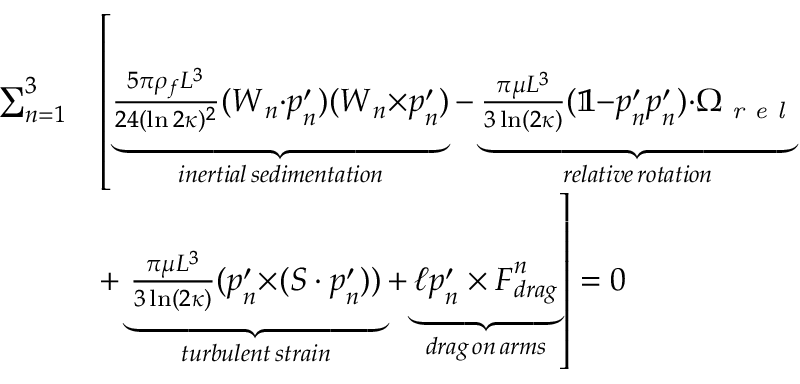<formula> <loc_0><loc_0><loc_500><loc_500>\begin{array} { r l } { \sum _ { n = 1 } ^ { 3 } } & { \left [ \underbrace { \frac { 5 \pi \rho _ { f } L ^ { 3 } } { 2 4 ( \ln 2 \kappa ) ^ { 2 } } ( W _ { n } { \cdot } p _ { n } ^ { \prime } ) ( W _ { n } { \times } p _ { n } ^ { \prime } ) } _ { i n e r t i a l \, s e d i m e n t a t i o n } - \underbrace { \frac { \pi \mu L ^ { 3 } } { 3 \ln ( 2 \kappa ) } ( \mathbb { 1 } { - } p _ { n } ^ { \prime } p _ { n } ^ { \prime } ) { \cdot } \Omega _ { r e l } } _ { r e l a t i v e \, r o t a t i o n } } \\ & { + \underbrace { \frac { \pi \mu L ^ { 3 } } { 3 \ln ( 2 \kappa ) } ( p _ { n } ^ { \prime } { \times } ( S \cdot p _ { n } ^ { \prime } ) ) } _ { t u r b u l e n t \, s t r a i n } + \underbrace { \ell p _ { n } ^ { \prime } \times F _ { d r a g } ^ { n } } _ { d r a g \, o n \, a r m s } \right ] = 0 } \end{array}</formula> 